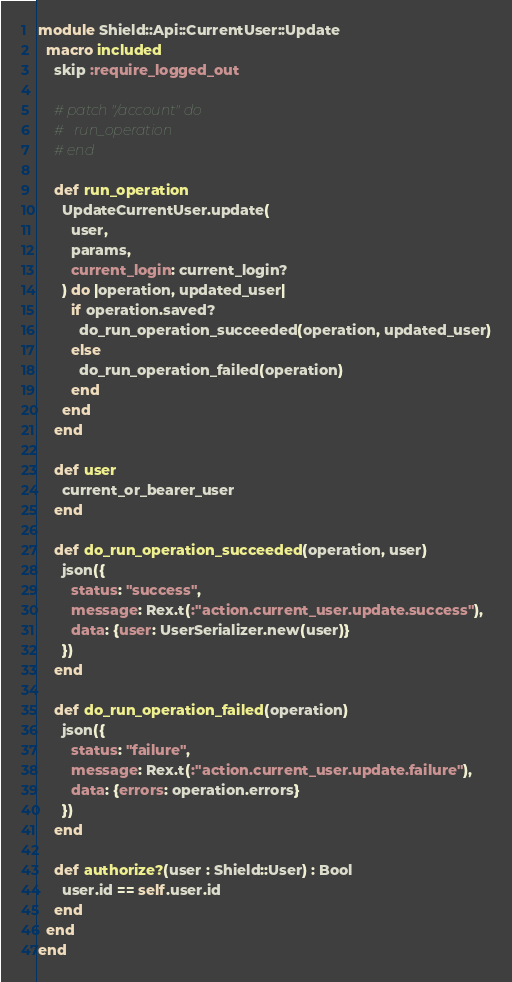Convert code to text. <code><loc_0><loc_0><loc_500><loc_500><_Crystal_>module Shield::Api::CurrentUser::Update
  macro included
    skip :require_logged_out

    # patch "/account" do
    #   run_operation
    # end

    def run_operation
      UpdateCurrentUser.update(
        user,
        params,
        current_login: current_login?
      ) do |operation, updated_user|
        if operation.saved?
          do_run_operation_succeeded(operation, updated_user)
        else
          do_run_operation_failed(operation)
        end
      end
    end

    def user
      current_or_bearer_user
    end

    def do_run_operation_succeeded(operation, user)
      json({
        status: "success",
        message: Rex.t(:"action.current_user.update.success"),
        data: {user: UserSerializer.new(user)}
      })
    end

    def do_run_operation_failed(operation)
      json({
        status: "failure",
        message: Rex.t(:"action.current_user.update.failure"),
        data: {errors: operation.errors}
      })
    end

    def authorize?(user : Shield::User) : Bool
      user.id == self.user.id
    end
  end
end
</code> 